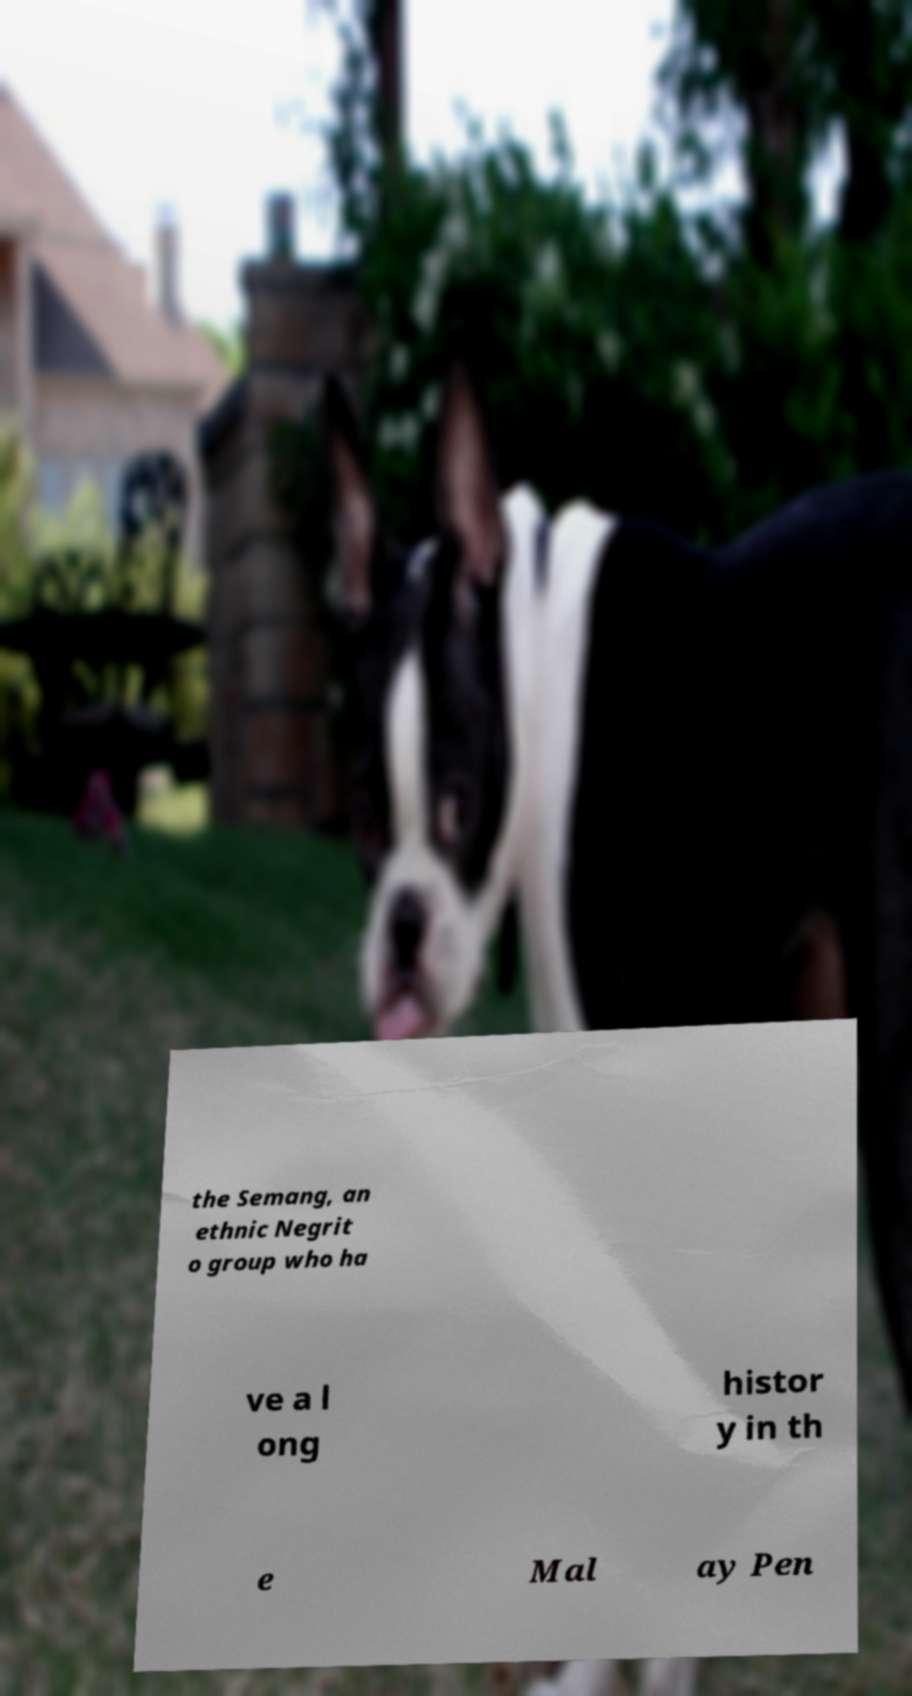Please read and relay the text visible in this image. What does it say? the Semang, an ethnic Negrit o group who ha ve a l ong histor y in th e Mal ay Pen 